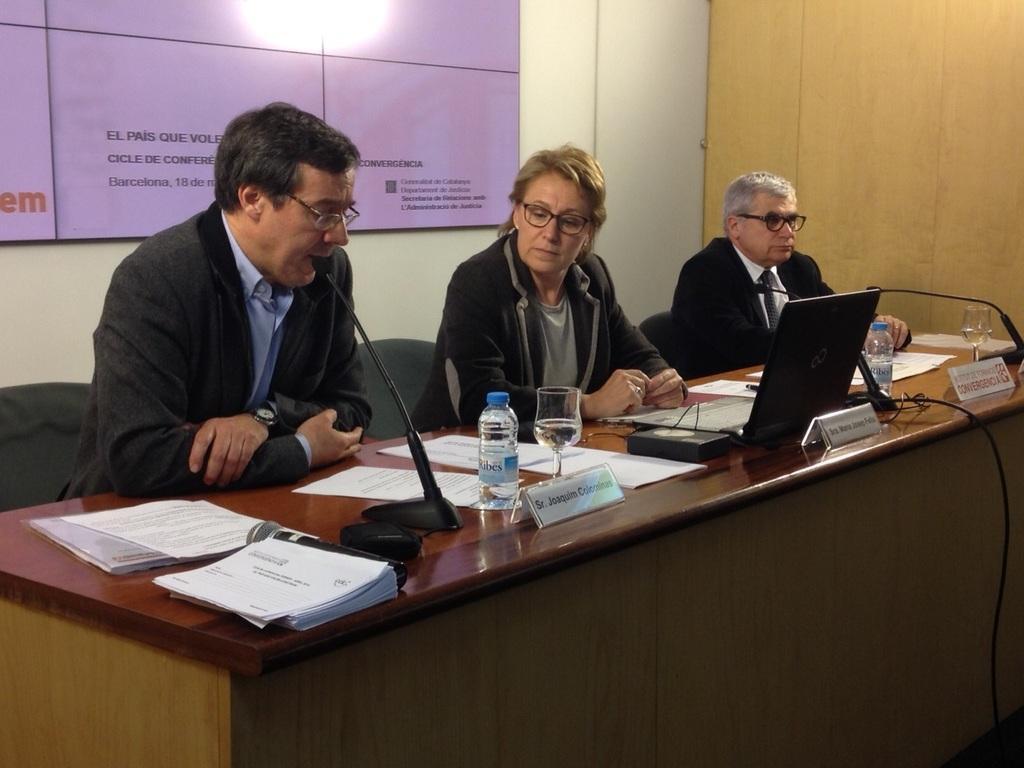Could you give a brief overview of what you see in this image? In this picture we can see three persons are sitting on chairs in front of a table, there are papers, bottles, glasses, name boards, microphones and a laptop on the table, in the background there is a board, we can see some text on the board. 